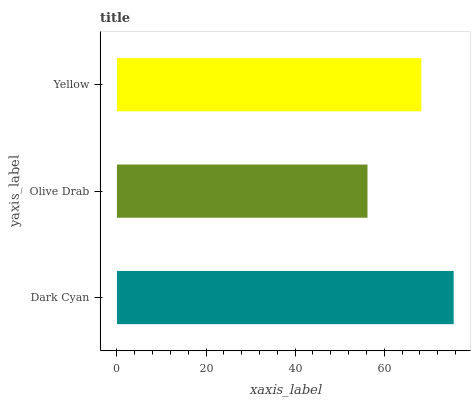Is Olive Drab the minimum?
Answer yes or no. Yes. Is Dark Cyan the maximum?
Answer yes or no. Yes. Is Yellow the minimum?
Answer yes or no. No. Is Yellow the maximum?
Answer yes or no. No. Is Yellow greater than Olive Drab?
Answer yes or no. Yes. Is Olive Drab less than Yellow?
Answer yes or no. Yes. Is Olive Drab greater than Yellow?
Answer yes or no. No. Is Yellow less than Olive Drab?
Answer yes or no. No. Is Yellow the high median?
Answer yes or no. Yes. Is Yellow the low median?
Answer yes or no. Yes. Is Dark Cyan the high median?
Answer yes or no. No. Is Dark Cyan the low median?
Answer yes or no. No. 